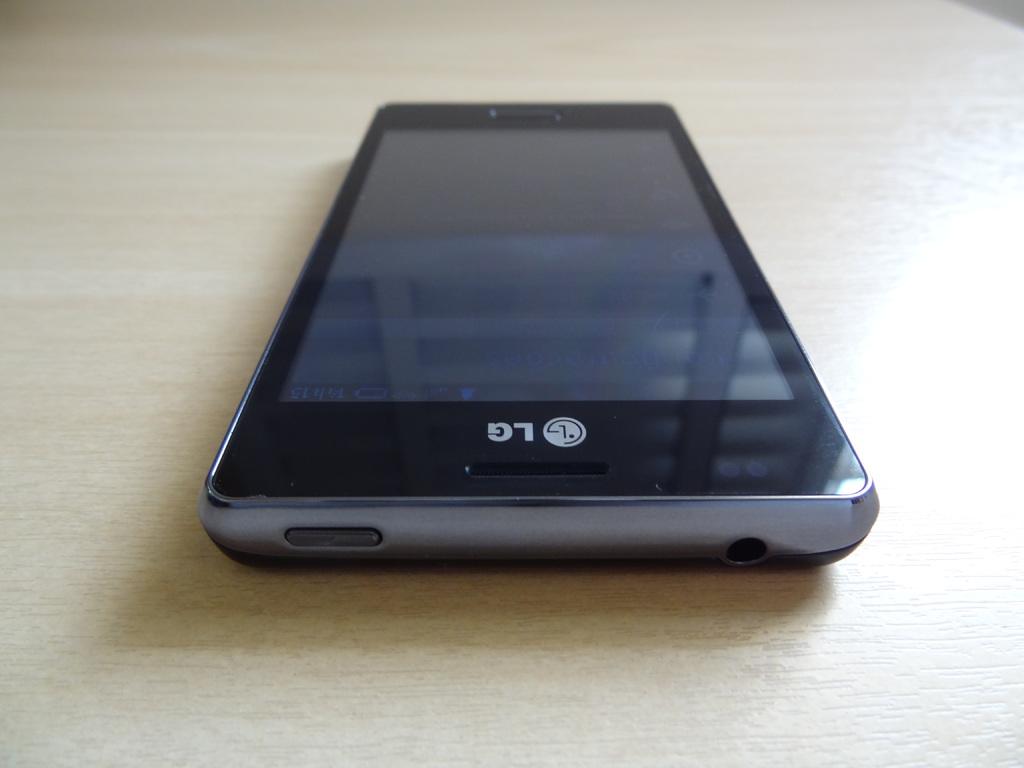What brand of phone is this?
Your answer should be very brief. Lg. What company logo is printed on the phone?
Ensure brevity in your answer.  Lg. 